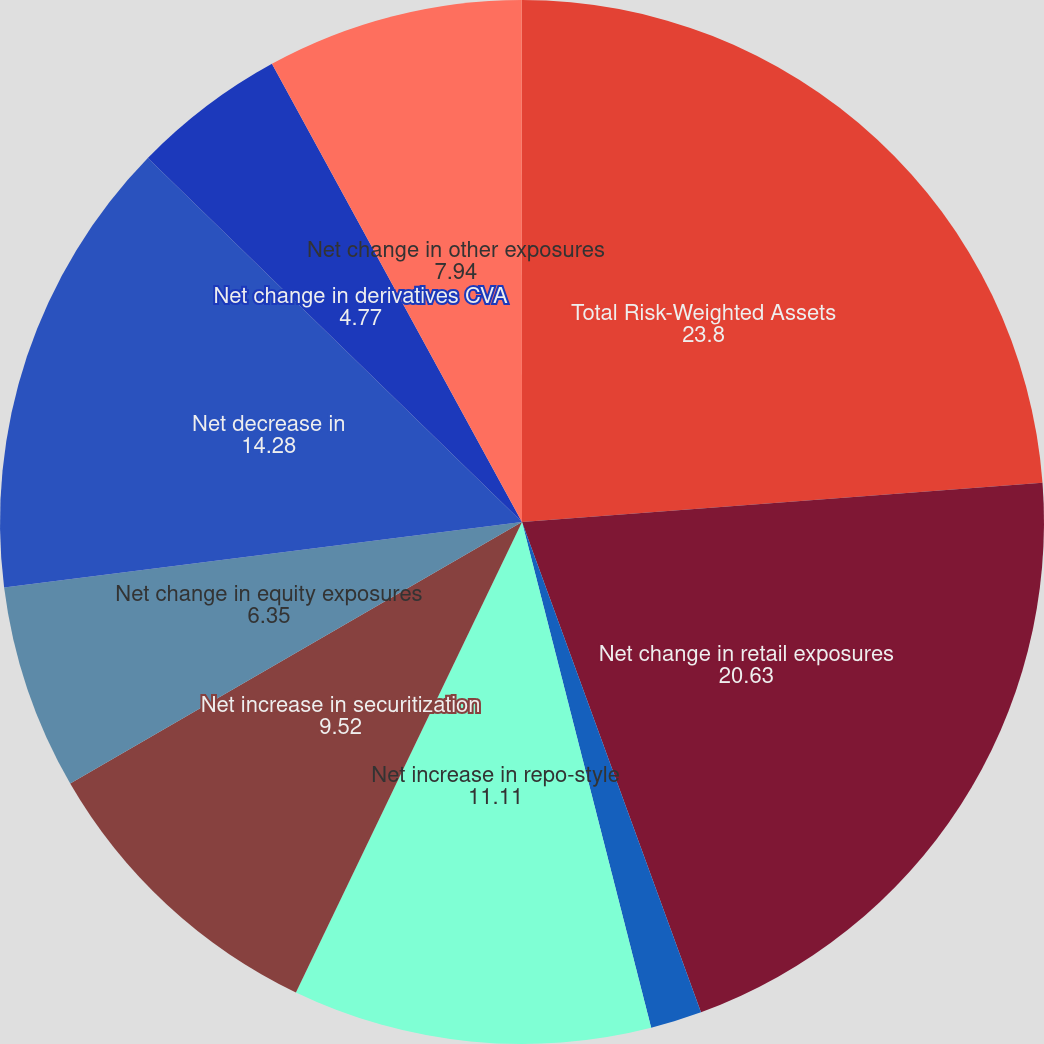Convert chart to OTSL. <chart><loc_0><loc_0><loc_500><loc_500><pie_chart><fcel>Total Risk-Weighted Assets<fcel>Net change in retail exposures<fcel>Net decrease in wholesale<fcel>Net increase in repo-style<fcel>Net increase in securitization<fcel>Net change in equity exposures<fcel>Net decrease in<fcel>Net change in derivatives CVA<fcel>Net change in other exposures<fcel>Net decrease in supervisory 6<nl><fcel>23.8%<fcel>20.63%<fcel>1.59%<fcel>11.11%<fcel>9.52%<fcel>6.35%<fcel>14.28%<fcel>4.77%<fcel>7.94%<fcel>0.01%<nl></chart> 